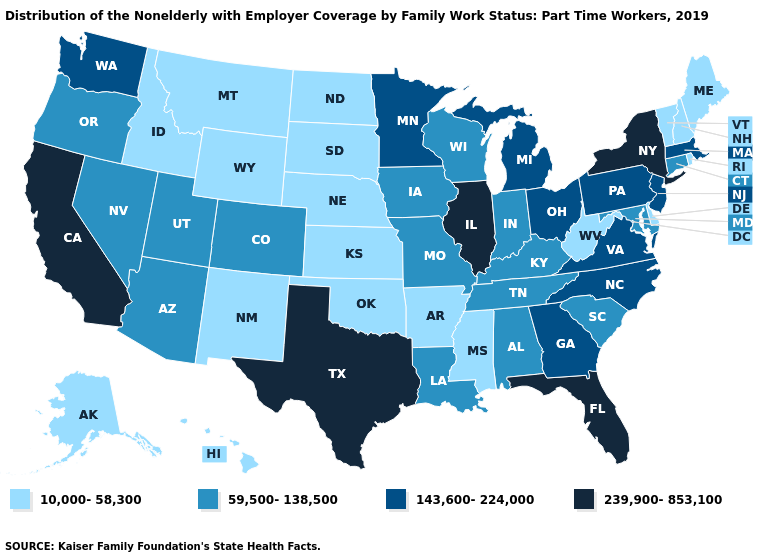Among the states that border Mississippi , does Alabama have the lowest value?
Give a very brief answer. No. Does South Carolina have the highest value in the USA?
Write a very short answer. No. Among the states that border Ohio , does West Virginia have the lowest value?
Quick response, please. Yes. Which states hav the highest value in the South?
Quick response, please. Florida, Texas. What is the value of South Carolina?
Short answer required. 59,500-138,500. Name the states that have a value in the range 239,900-853,100?
Answer briefly. California, Florida, Illinois, New York, Texas. Which states hav the highest value in the MidWest?
Short answer required. Illinois. What is the value of Rhode Island?
Be succinct. 10,000-58,300. Name the states that have a value in the range 239,900-853,100?
Keep it brief. California, Florida, Illinois, New York, Texas. What is the value of Maryland?
Short answer required. 59,500-138,500. Among the states that border West Virginia , which have the highest value?
Answer briefly. Ohio, Pennsylvania, Virginia. What is the highest value in the MidWest ?
Be succinct. 239,900-853,100. What is the value of Maryland?
Short answer required. 59,500-138,500. Does California have the highest value in the USA?
Short answer required. Yes. Does the map have missing data?
Write a very short answer. No. 